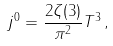Convert formula to latex. <formula><loc_0><loc_0><loc_500><loc_500>j ^ { 0 } = \frac { 2 \zeta ( 3 ) } { \pi ^ { 2 } } T ^ { 3 } \, ,</formula> 